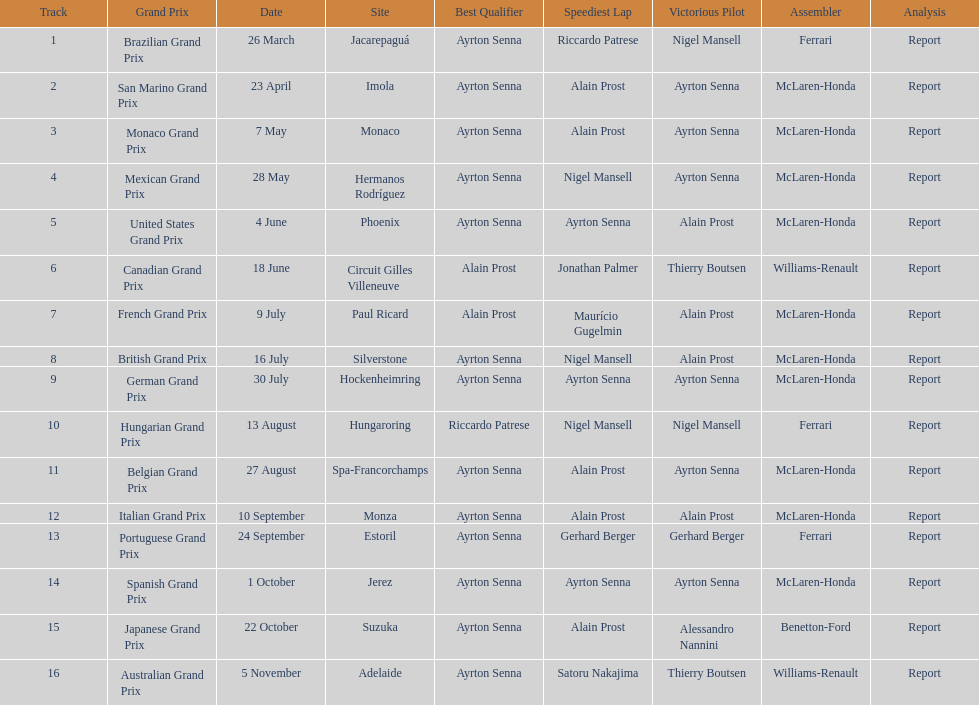How many times was ayrton senna in pole position? 13. 